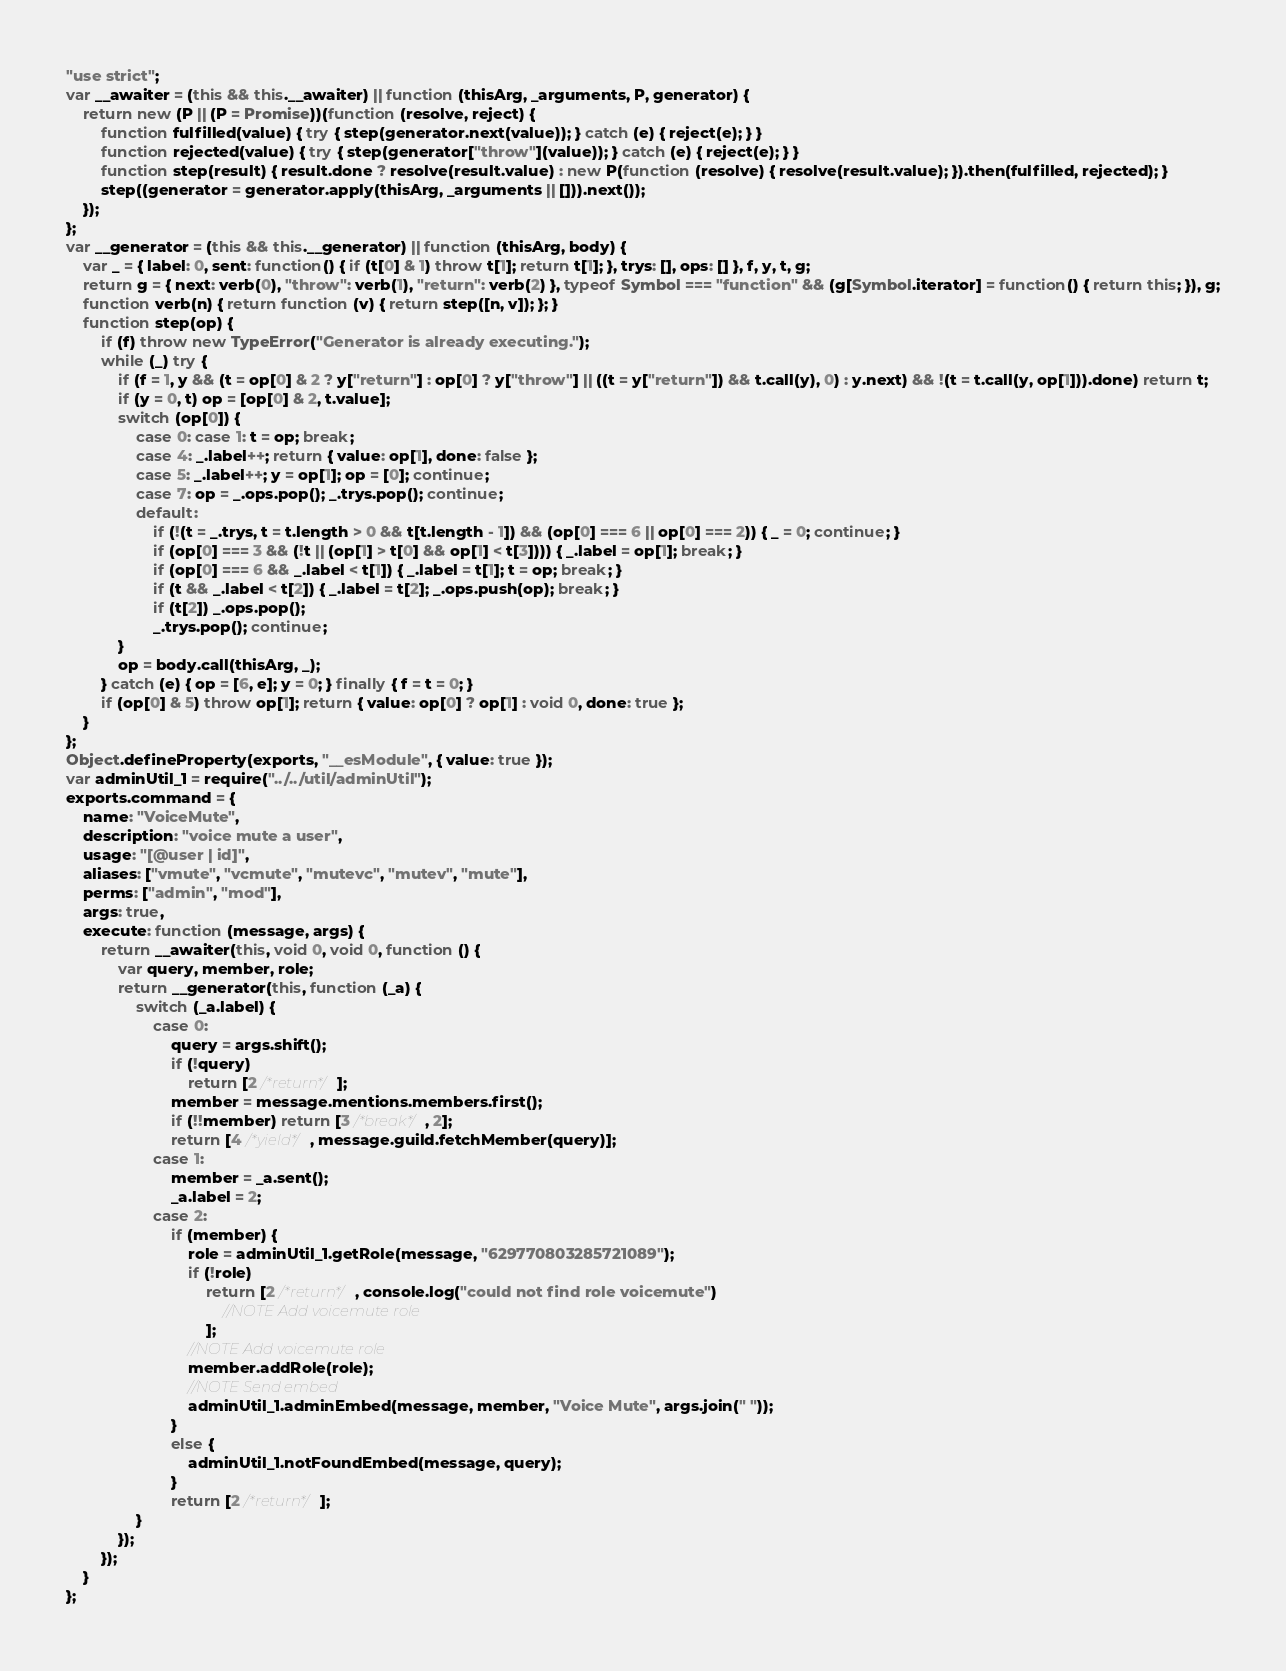Convert code to text. <code><loc_0><loc_0><loc_500><loc_500><_JavaScript_>"use strict";
var __awaiter = (this && this.__awaiter) || function (thisArg, _arguments, P, generator) {
    return new (P || (P = Promise))(function (resolve, reject) {
        function fulfilled(value) { try { step(generator.next(value)); } catch (e) { reject(e); } }
        function rejected(value) { try { step(generator["throw"](value)); } catch (e) { reject(e); } }
        function step(result) { result.done ? resolve(result.value) : new P(function (resolve) { resolve(result.value); }).then(fulfilled, rejected); }
        step((generator = generator.apply(thisArg, _arguments || [])).next());
    });
};
var __generator = (this && this.__generator) || function (thisArg, body) {
    var _ = { label: 0, sent: function() { if (t[0] & 1) throw t[1]; return t[1]; }, trys: [], ops: [] }, f, y, t, g;
    return g = { next: verb(0), "throw": verb(1), "return": verb(2) }, typeof Symbol === "function" && (g[Symbol.iterator] = function() { return this; }), g;
    function verb(n) { return function (v) { return step([n, v]); }; }
    function step(op) {
        if (f) throw new TypeError("Generator is already executing.");
        while (_) try {
            if (f = 1, y && (t = op[0] & 2 ? y["return"] : op[0] ? y["throw"] || ((t = y["return"]) && t.call(y), 0) : y.next) && !(t = t.call(y, op[1])).done) return t;
            if (y = 0, t) op = [op[0] & 2, t.value];
            switch (op[0]) {
                case 0: case 1: t = op; break;
                case 4: _.label++; return { value: op[1], done: false };
                case 5: _.label++; y = op[1]; op = [0]; continue;
                case 7: op = _.ops.pop(); _.trys.pop(); continue;
                default:
                    if (!(t = _.trys, t = t.length > 0 && t[t.length - 1]) && (op[0] === 6 || op[0] === 2)) { _ = 0; continue; }
                    if (op[0] === 3 && (!t || (op[1] > t[0] && op[1] < t[3]))) { _.label = op[1]; break; }
                    if (op[0] === 6 && _.label < t[1]) { _.label = t[1]; t = op; break; }
                    if (t && _.label < t[2]) { _.label = t[2]; _.ops.push(op); break; }
                    if (t[2]) _.ops.pop();
                    _.trys.pop(); continue;
            }
            op = body.call(thisArg, _);
        } catch (e) { op = [6, e]; y = 0; } finally { f = t = 0; }
        if (op[0] & 5) throw op[1]; return { value: op[0] ? op[1] : void 0, done: true };
    }
};
Object.defineProperty(exports, "__esModule", { value: true });
var adminUtil_1 = require("../../util/adminUtil");
exports.command = {
    name: "VoiceMute",
    description: "voice mute a user",
    usage: "[@user | id]",
    aliases: ["vmute", "vcmute", "mutevc", "mutev", "mute"],
    perms: ["admin", "mod"],
    args: true,
    execute: function (message, args) {
        return __awaiter(this, void 0, void 0, function () {
            var query, member, role;
            return __generator(this, function (_a) {
                switch (_a.label) {
                    case 0:
                        query = args.shift();
                        if (!query)
                            return [2 /*return*/];
                        member = message.mentions.members.first();
                        if (!!member) return [3 /*break*/, 2];
                        return [4 /*yield*/, message.guild.fetchMember(query)];
                    case 1:
                        member = _a.sent();
                        _a.label = 2;
                    case 2:
                        if (member) {
                            role = adminUtil_1.getRole(message, "629770803285721089");
                            if (!role)
                                return [2 /*return*/, console.log("could not find role voicemute")
                                    //NOTE Add voicemute role
                                ];
                            //NOTE Add voicemute role
                            member.addRole(role);
                            //NOTE Send embed
                            adminUtil_1.adminEmbed(message, member, "Voice Mute", args.join(" "));
                        }
                        else {
                            adminUtil_1.notFoundEmbed(message, query);
                        }
                        return [2 /*return*/];
                }
            });
        });
    }
};
</code> 